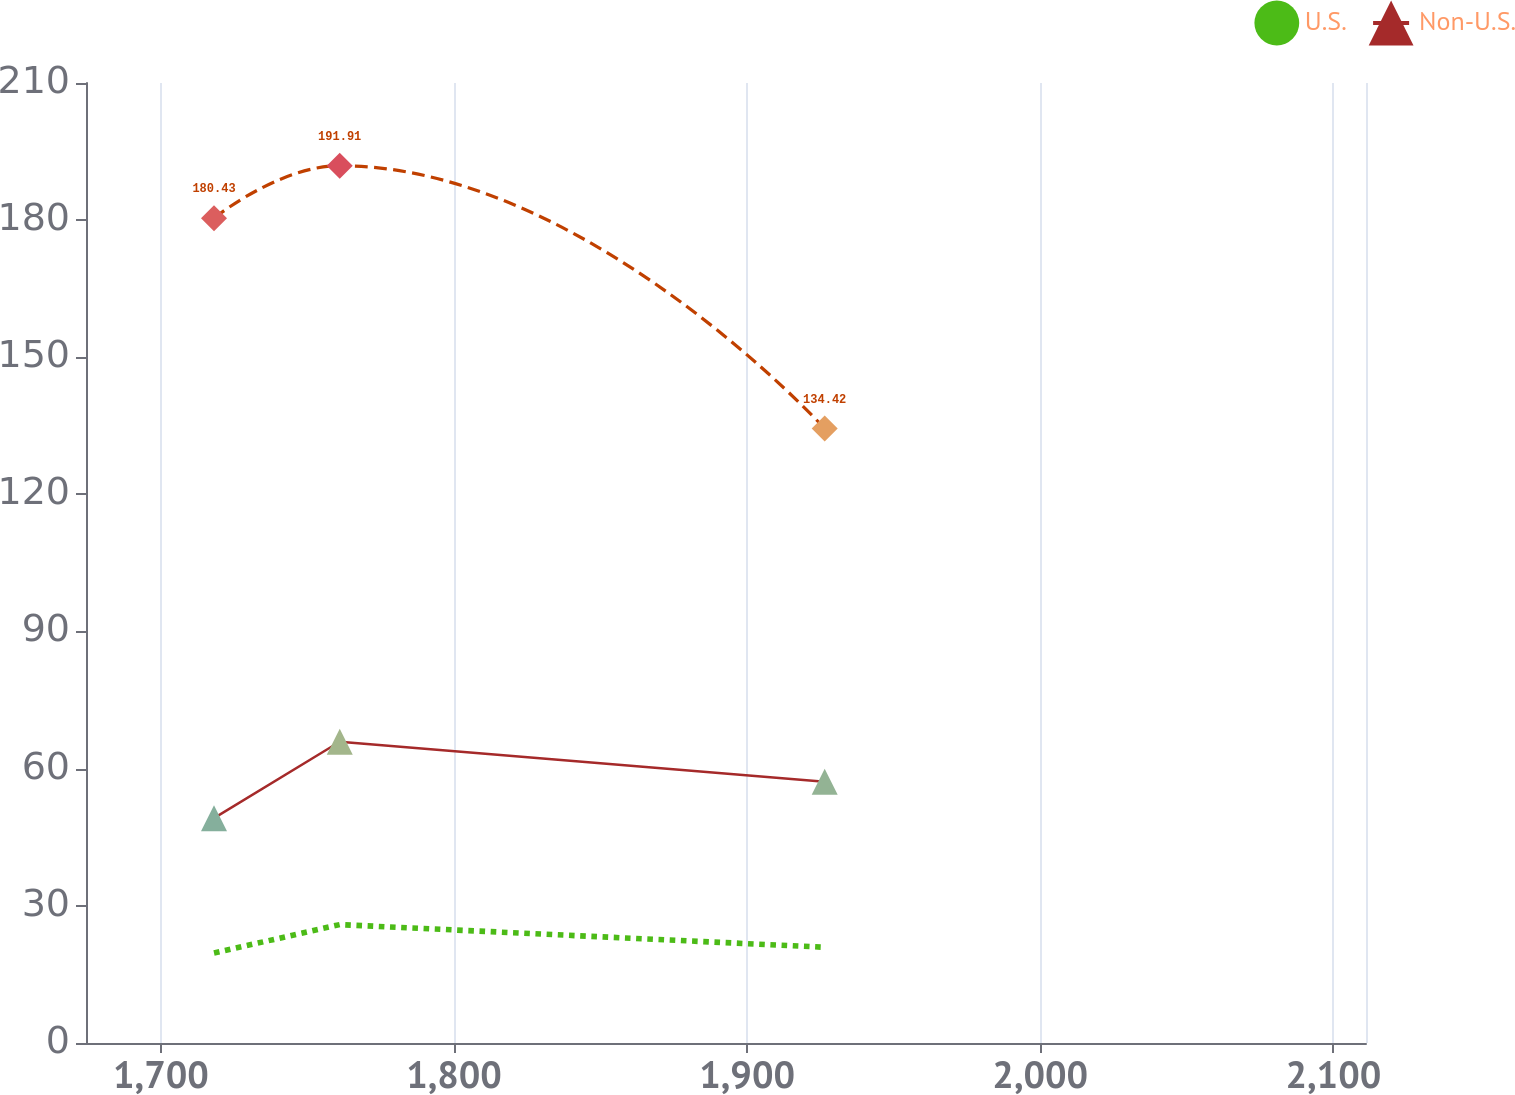Convert chart to OTSL. <chart><loc_0><loc_0><loc_500><loc_500><line_chart><ecel><fcel>Unnamed: 1<fcel>U.S.<fcel>Non-U.S.<nl><fcel>1718.12<fcel>180.43<fcel>19.7<fcel>49.19<nl><fcel>1761.01<fcel>191.91<fcel>25.9<fcel>65.9<nl><fcel>1926.46<fcel>134.42<fcel>20.94<fcel>57.14<nl><fcel>2111.9<fcel>128.03<fcel>22.34<fcel>54.76<nl><fcel>2154.8<fcel>157.04<fcel>32.06<fcel>42.08<nl></chart> 